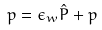Convert formula to latex. <formula><loc_0><loc_0><loc_500><loc_500>p = \epsilon _ { w } \hat { P } + p</formula> 